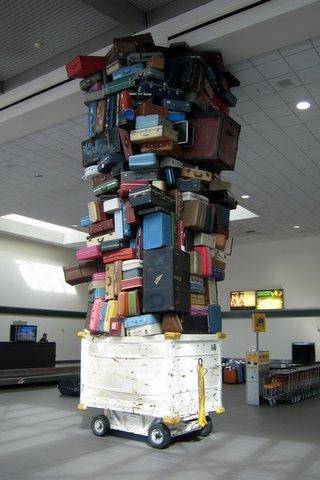What area of the airport is this?
Short answer required. Baggage. Does this look normal?
Give a very brief answer. No. Does this look safe?
Short answer required. No. 